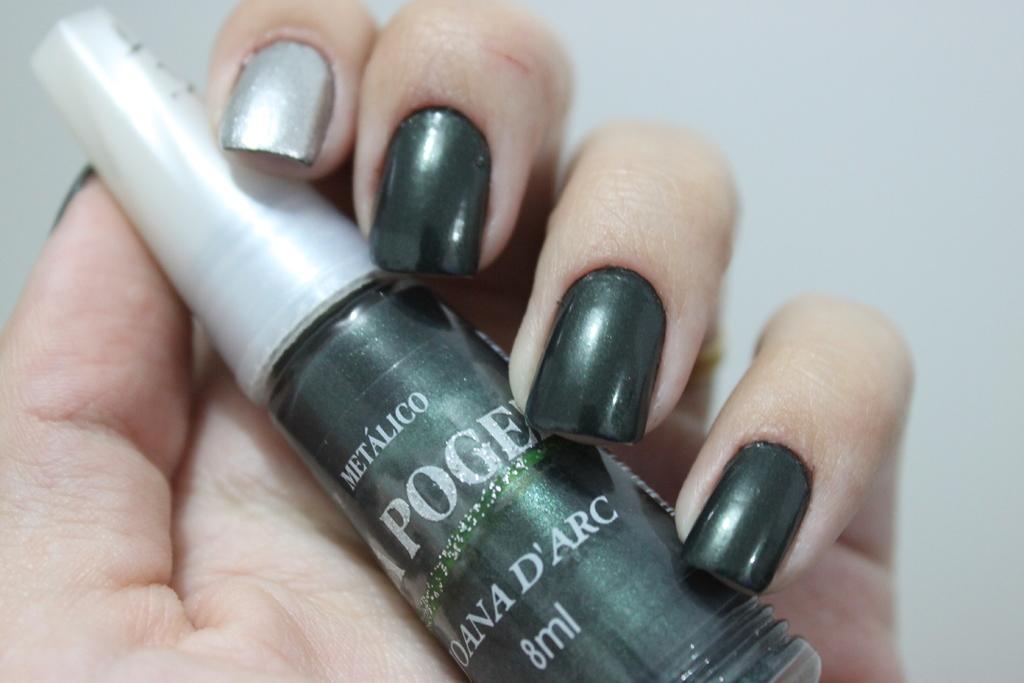What brand is this nail polish?
Your response must be concise. Metalico. 